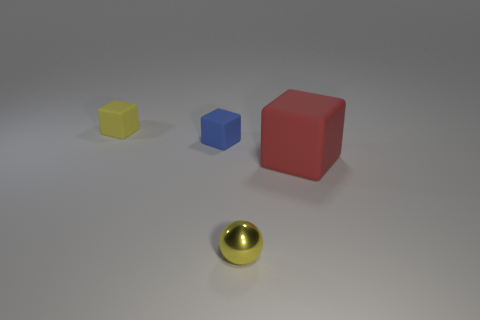Is there a small cube that has the same color as the small metallic sphere?
Make the answer very short. Yes. The large thing that is made of the same material as the tiny blue thing is what color?
Keep it short and to the point. Red. What shape is the yellow thing that is the same size as the yellow shiny ball?
Offer a terse response. Cube. The yellow rubber object is what size?
Keep it short and to the point. Small. There is a yellow thing that is behind the small yellow sphere; does it have the same size as the yellow thing that is right of the yellow block?
Provide a succinct answer. Yes. There is a small cube in front of the small matte block that is behind the blue thing; what color is it?
Give a very brief answer. Blue. What is the material of the yellow sphere that is the same size as the yellow cube?
Offer a terse response. Metal. How many rubber things are tiny red cylinders or tiny yellow blocks?
Your answer should be very brief. 1. There is a object that is to the right of the tiny blue matte cube and behind the tiny metal sphere; what color is it?
Your answer should be very brief. Red. There is a large matte thing; what number of small cubes are in front of it?
Offer a very short reply. 0. 